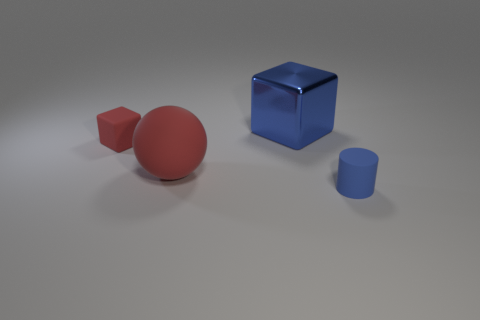What is the material of the tiny thing that is to the right of the tiny thing that is on the left side of the blue object that is in front of the blue shiny cube?
Your answer should be compact. Rubber. What is the material of the small object that is the same color as the big metallic block?
Offer a very short reply. Rubber. What number of tiny objects are the same material as the big ball?
Keep it short and to the point. 2. Is the size of the rubber cylinder that is to the right of the blue shiny cube the same as the metallic thing?
Make the answer very short. No. The large sphere that is the same material as the cylinder is what color?
Provide a succinct answer. Red. Is there any other thing that has the same size as the blue rubber cylinder?
Give a very brief answer. Yes. What number of small things are in front of the tiny red matte thing?
Offer a terse response. 1. Is the color of the tiny matte thing that is behind the small blue rubber object the same as the tiny rubber thing on the right side of the large metallic block?
Provide a short and direct response. No. What is the color of the large metal thing that is the same shape as the tiny red thing?
Give a very brief answer. Blue. Is there any other thing that has the same shape as the large red thing?
Your response must be concise. No. 